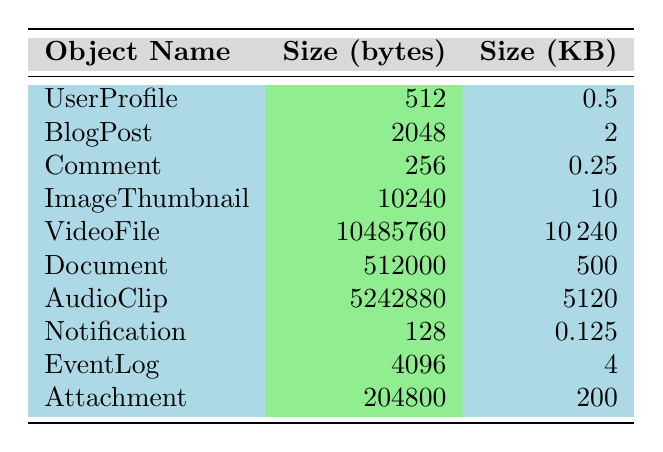What is the size of the VideoFile? The size of the VideoFile is listed directly in the table as 10,485,760 bytes.
Answer: 10,485,760 bytes How many objects have a size greater than 5,000,000 bytes? By examining the table, only the VideoFile (10,485,760 bytes) and AudioClip (5,242,880 bytes) exceed 5,000,000 bytes. Therefore, there are two such objects.
Answer: 2 What is the total size of all objects listed? To find the total size, we sum the sizes: 512 (UserProfile) + 2048 (BlogPost) + 256 (Comment) + 10240 (ImageThumbnail) + 10485760 (VideoFile) + 512000 (Document) + 5242880 (AudioClip) + 128 (Notification) + 4096 (EventLog) + 204800 (Attachment) = 10,736,288 bytes.
Answer: 10,736,288 bytes Is the size of the Document larger than the size of the ImageThumbnail? The size of the Document is 512,000 bytes, while the size of the ImageThumbnail is 10,240 bytes. Since 512,000 is larger than 10,240, the answer is yes.
Answer: Yes What is the average size of all objects in kilobytes? First, we convert each size to kilobytes by dividing by 1024 and then sum them: (512/1024) + (2048/1024) + (256/1024) + (10240/1024) + (10485760/1024) + (512000/1024) + (5242880/1024) + (128/1024) + (4096/1024) + (204800/1024) = 10,486.25 KB. There are 10 objects, so the average is 10,486.25/10 = 1,048.625 KB.
Answer: 1,048.625 KB Which object has the smallest size, and what is that size? Looking through the sizes listed, the smallest size is for the Notification, which is 128 bytes.
Answer: Notification, 128 bytes What is the difference in size between the largest and smallest objects? The largest object is the VideoFile at 10,485,760 bytes and the smallest is the Notification at 128 bytes. The difference in size is calculated as 10,485,760 - 128 = 10,485,632 bytes.
Answer: 10,485,632 bytes Are there any objects smaller than 1 KB? By checking the sizes, the objects Comment (256 bytes) and Notification (128 bytes) are both smaller than 1 KB, confirming there are objects that meet this criterion.
Answer: Yes What fraction of the total size do the BlogPost and UserProfile represent combined? The size of the BlogPost is 2,048 bytes, and the UserProfile is 512 bytes. Combined, they are 2,560 bytes. The total size is 10,736,288 bytes, so the fraction is 2,560/10,736,288, which simplifies to approximately 0.000238 (or around 0.0238%).
Answer: Approximately 0.000238 or 0.0238% 